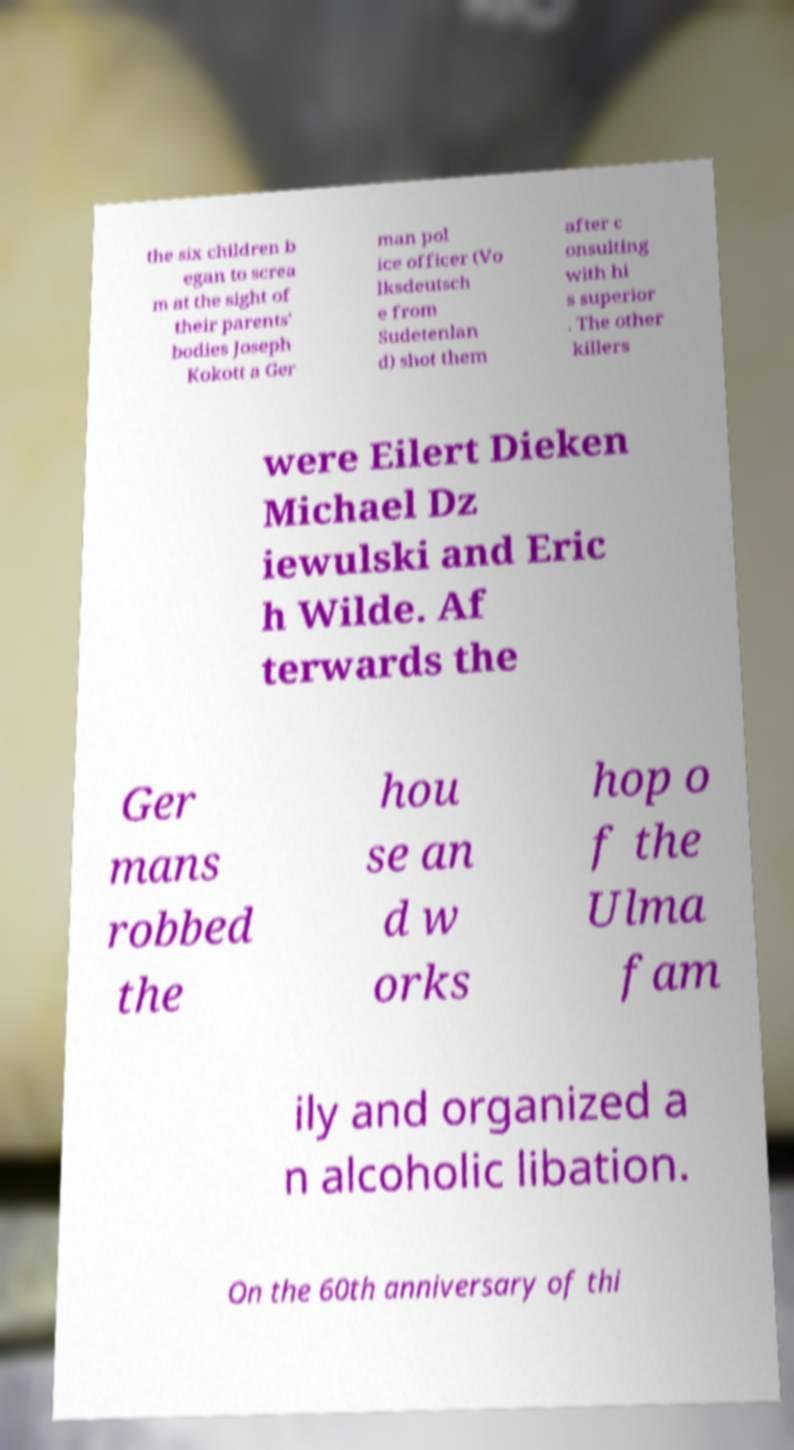I need the written content from this picture converted into text. Can you do that? the six children b egan to screa m at the sight of their parents' bodies Joseph Kokott a Ger man pol ice officer (Vo lksdeutsch e from Sudetenlan d) shot them after c onsulting with hi s superior . The other killers were Eilert Dieken Michael Dz iewulski and Eric h Wilde. Af terwards the Ger mans robbed the hou se an d w orks hop o f the Ulma fam ily and organized a n alcoholic libation. On the 60th anniversary of thi 